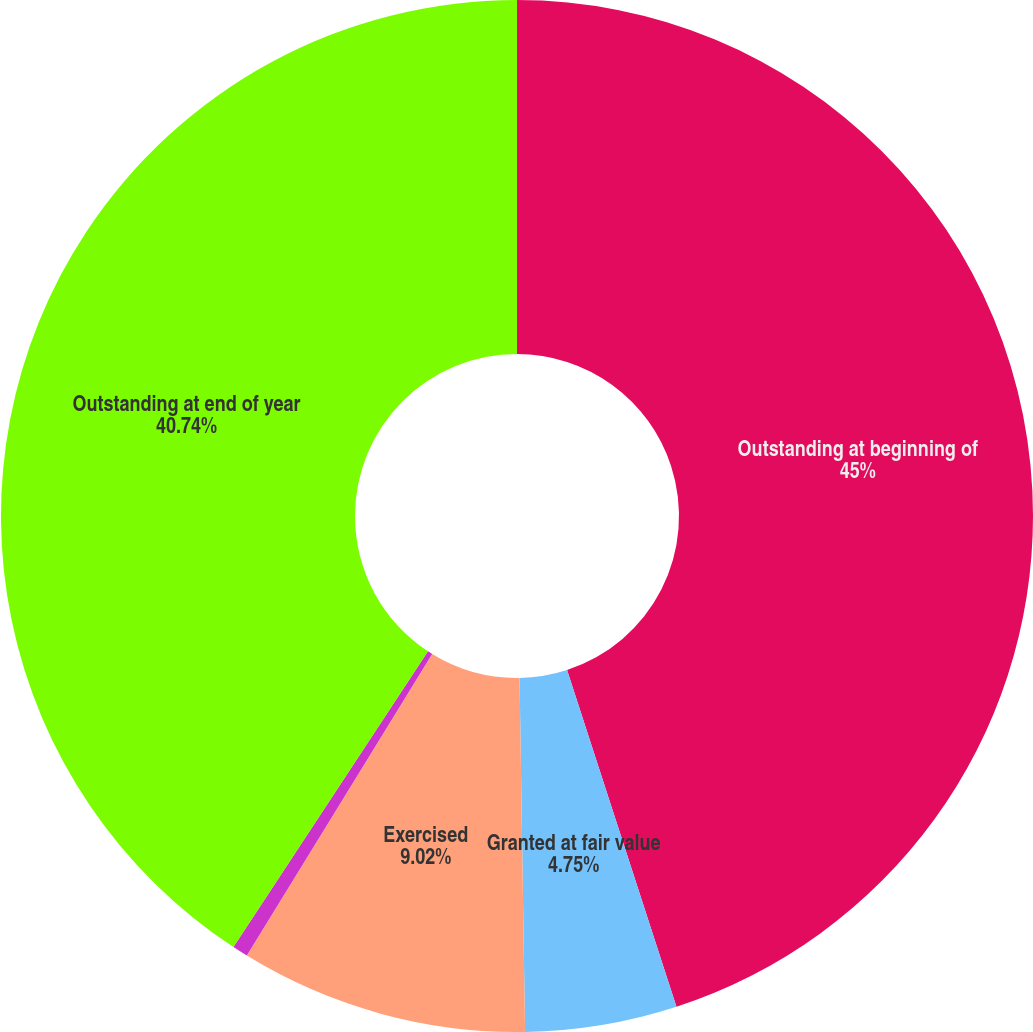Convert chart. <chart><loc_0><loc_0><loc_500><loc_500><pie_chart><fcel>Outstanding at beginning of<fcel>Granted at fair value<fcel>Exercised<fcel>Cancelled or expired<fcel>Outstanding at end of year<nl><fcel>45.0%<fcel>4.75%<fcel>9.02%<fcel>0.49%<fcel>40.74%<nl></chart> 